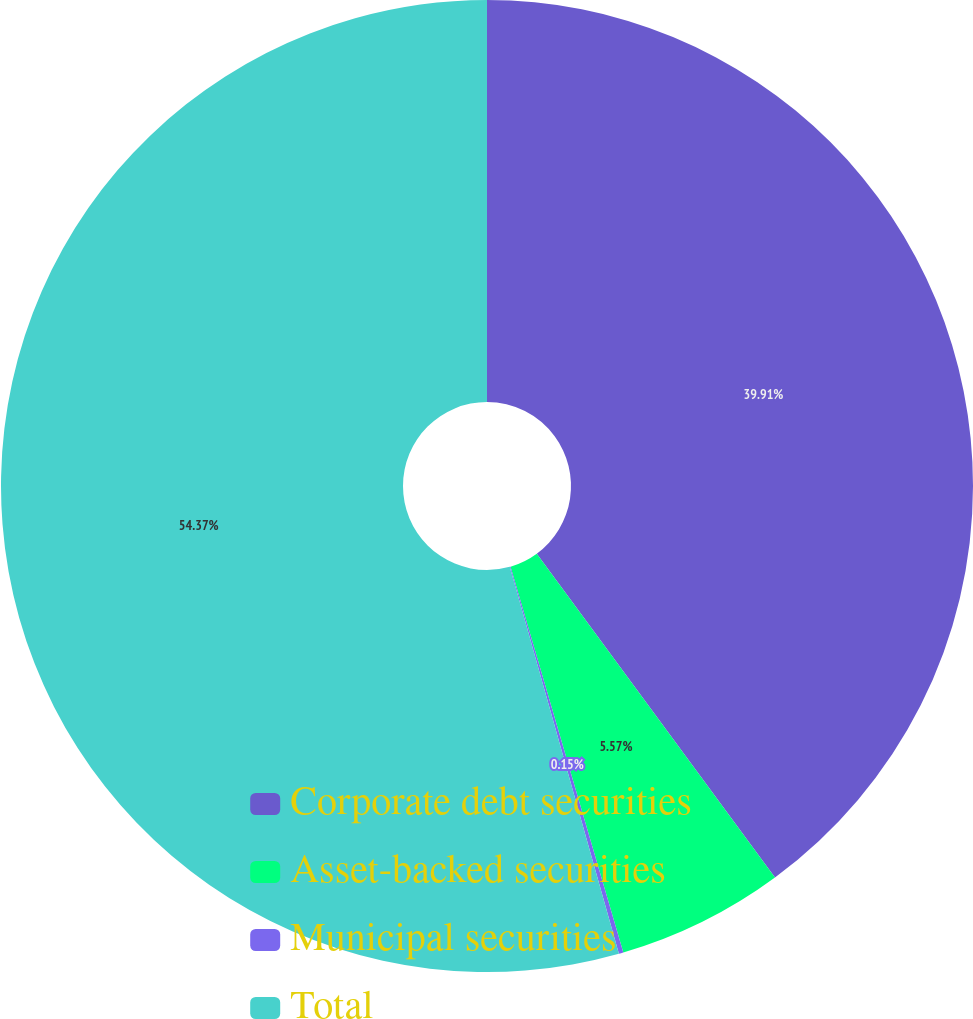Convert chart to OTSL. <chart><loc_0><loc_0><loc_500><loc_500><pie_chart><fcel>Corporate debt securities<fcel>Asset-backed securities<fcel>Municipal securities<fcel>Total<nl><fcel>39.91%<fcel>5.57%<fcel>0.15%<fcel>54.38%<nl></chart> 